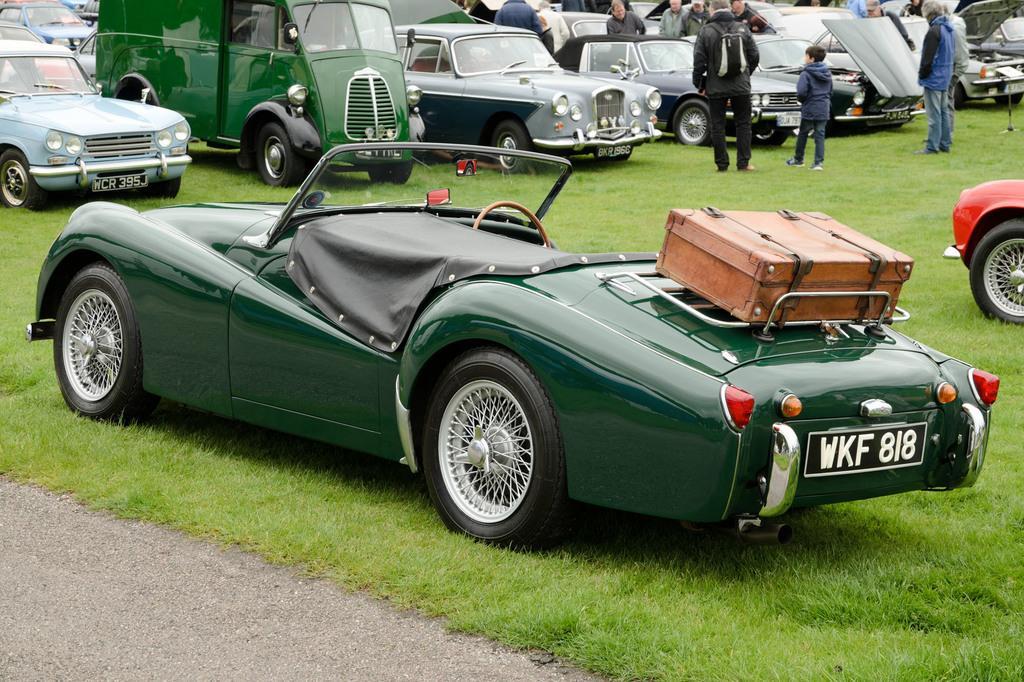Can you describe this image briefly? In this image I can see the road, some grass on the ground, a car which is green in color and a box which is brown in color on the car. In the background I can see few persons standing and few vehicles on the ground. 